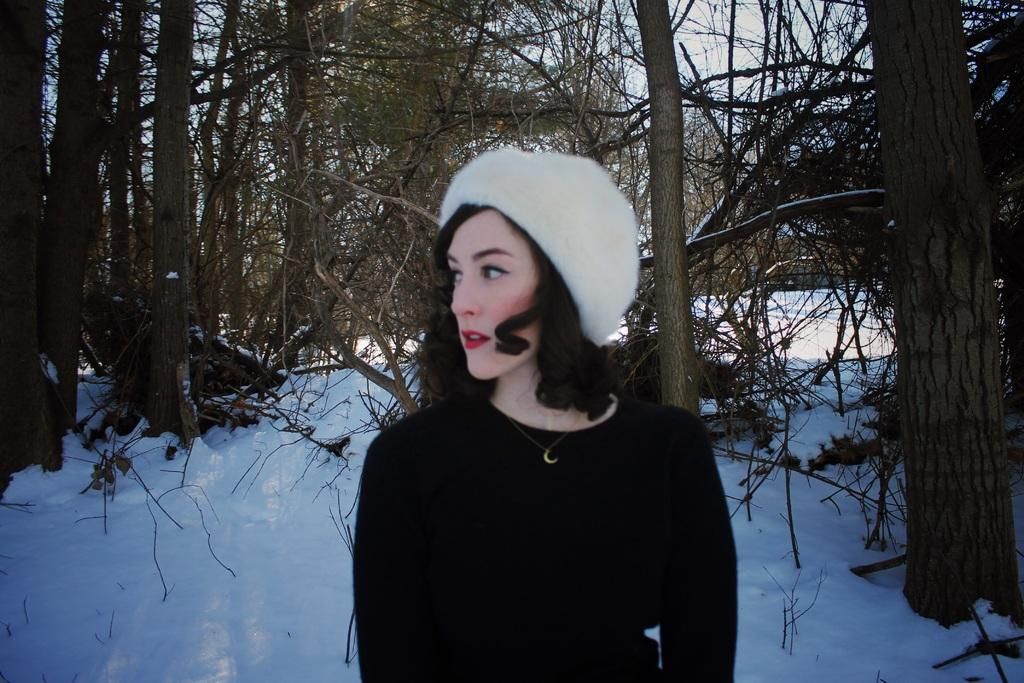What is the weather like in the image? There is snow in the image, indicating a cold and wintry setting. Can you describe the woman's attire in the image? The woman is wearing a black dress and a white hat. What can be seen in the background of the image? There are trees in the background of the image. What color is the door in the image? There is no door present in the image. What discovery was made by the woman in the image? There is no indication of a discovery being made in the image. 